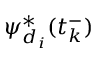<formula> <loc_0><loc_0><loc_500><loc_500>\psi _ { d _ { i } } ^ { * } ( t _ { k } ^ { - } )</formula> 